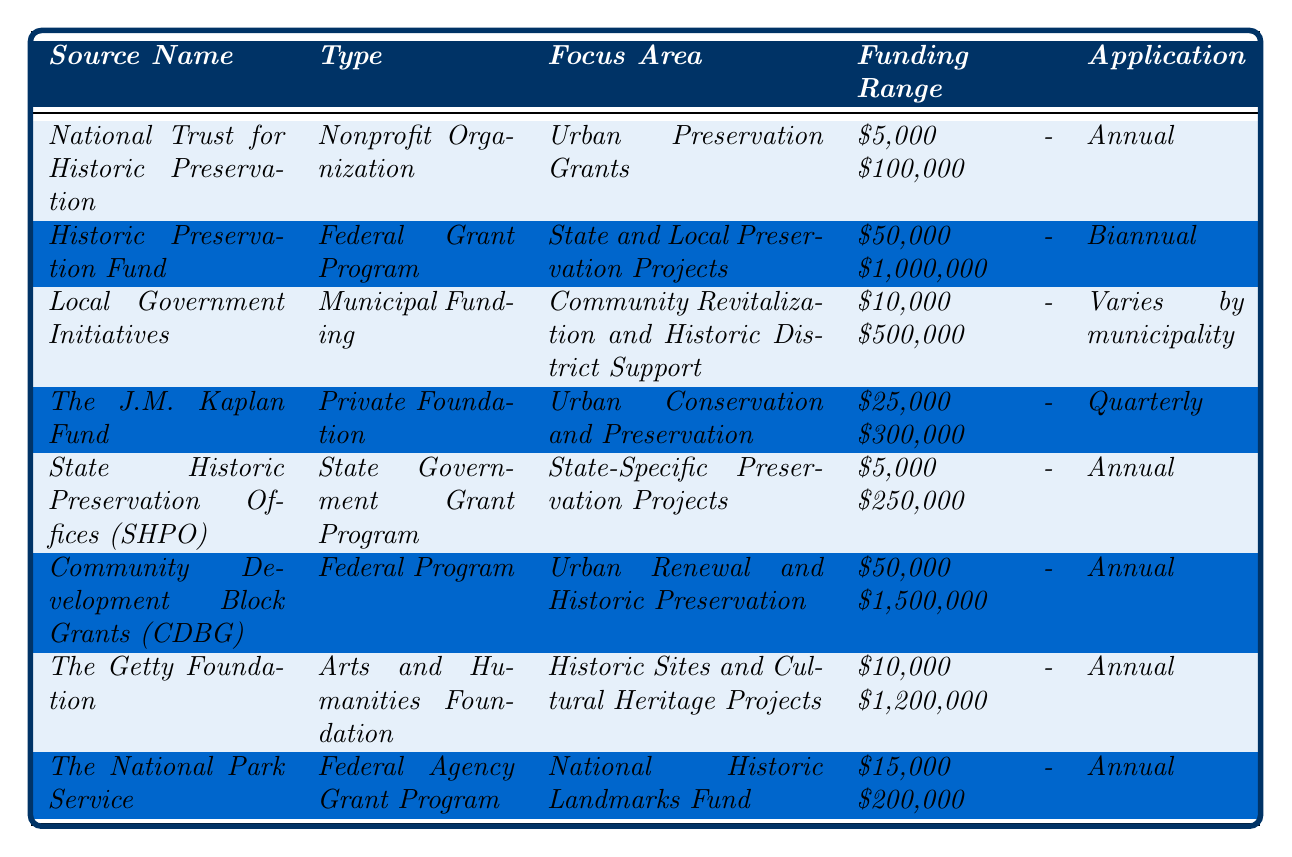What is the funding range provided by the National Trust for Historic Preservation? According to the table, the funding range for the National Trust for Historic Preservation is listed as $5,000 to $100,000.
Answer: $5,000 - $100,000 How often can applications be submitted for the Historic Preservation Fund? The table indicates that the Historic Preservation Fund accepts applications biannually.
Answer: Biannual Which funding source has the highest potential funding amount range? In the table, the Community Development Block Grants (CDBG) show a funding range of $50,000 to $1,500,000, which is the highest range listed.
Answer: $50,000 - $1,500,000 Is the funding from Local Government Initiatives consistent across all municipalities? The table specifies that the application frequency for Local Government Initiatives varies by municipality, indicating inconsistency.
Answer: No What is the total maximum funding amount range of the four federal programs? The four federal programs listed are the Historic Preservation Fund ($1,000,000), Community Development Block Grants (CDBG) ($1,500,000), The National Park Service ($200,000), and none from CDBG, which sums up to $2,700,000.
Answer: $2,700,000 Which funding source allows for the most frequent applications? The table shows that The J.M. Kaplan Fund allows applications quarterly, which is more frequent than any other source listed.
Answer: The J.M. Kaplan Fund How do the funding ranges of the National Trust for Historic Preservation and State Historic Preservation Offices (SHPO) compare? The National Trust for Historic Preservation has a funding range of $5,000 - $100,000, whereas SHPO has a range of $5,000 - $250,000. The SHPO is broader with a higher maximum funding amount.
Answer: SHPO is broader What type of funding source does the Getty Foundation represent? The table categorizes the Getty Foundation as an Arts and Humanities Foundation.
Answer: Arts and Humanities Foundation Which funding source supports Urban Renewal and Historic Preservation and what is its application frequency? The Community Development Block Grants (CDBG) focus on Urban Renewal and Historic Preservation, with an application frequency of annually.
Answer: Annual What is the median funding amount range across all the funding sources listed? To find the median funding range, convert ranges to their midpoints: 52,500, 525,000, 17,500, 162,500, 127,500, 775,000, 605,000, and 107,500. The median is 127,500.
Answer: $127,500 